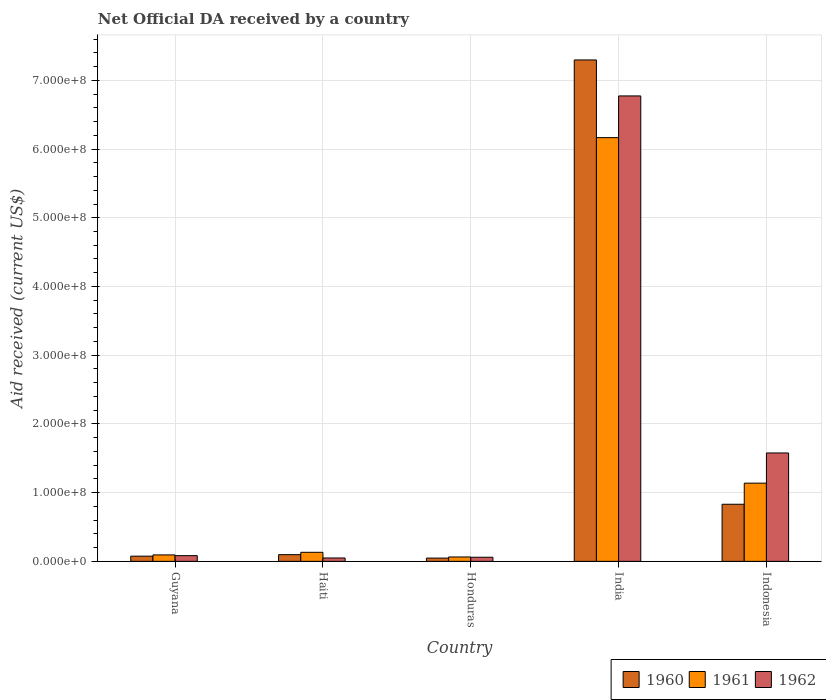How many different coloured bars are there?
Provide a succinct answer. 3. Are the number of bars per tick equal to the number of legend labels?
Your answer should be very brief. Yes. How many bars are there on the 2nd tick from the left?
Offer a terse response. 3. What is the net official development assistance aid received in 1962 in Haiti?
Give a very brief answer. 4.92e+06. Across all countries, what is the maximum net official development assistance aid received in 1960?
Provide a short and direct response. 7.30e+08. Across all countries, what is the minimum net official development assistance aid received in 1960?
Make the answer very short. 4.77e+06. In which country was the net official development assistance aid received in 1961 minimum?
Your answer should be very brief. Honduras. What is the total net official development assistance aid received in 1960 in the graph?
Offer a very short reply. 8.35e+08. What is the difference between the net official development assistance aid received in 1961 in India and that in Indonesia?
Give a very brief answer. 5.03e+08. What is the difference between the net official development assistance aid received in 1961 in India and the net official development assistance aid received in 1960 in Indonesia?
Offer a very short reply. 5.34e+08. What is the average net official development assistance aid received in 1960 per country?
Provide a short and direct response. 1.67e+08. What is the difference between the net official development assistance aid received of/in 1962 and net official development assistance aid received of/in 1961 in Guyana?
Ensure brevity in your answer.  -1.06e+06. What is the ratio of the net official development assistance aid received in 1962 in Honduras to that in Indonesia?
Provide a succinct answer. 0.04. Is the net official development assistance aid received in 1960 in Honduras less than that in India?
Offer a terse response. Yes. Is the difference between the net official development assistance aid received in 1962 in Guyana and Honduras greater than the difference between the net official development assistance aid received in 1961 in Guyana and Honduras?
Make the answer very short. No. What is the difference between the highest and the second highest net official development assistance aid received in 1961?
Make the answer very short. 5.03e+08. What is the difference between the highest and the lowest net official development assistance aid received in 1961?
Give a very brief answer. 6.10e+08. Is the sum of the net official development assistance aid received in 1961 in India and Indonesia greater than the maximum net official development assistance aid received in 1960 across all countries?
Your answer should be very brief. Yes. Is it the case that in every country, the sum of the net official development assistance aid received in 1960 and net official development assistance aid received in 1962 is greater than the net official development assistance aid received in 1961?
Make the answer very short. Yes. How many bars are there?
Offer a terse response. 15. Are all the bars in the graph horizontal?
Your response must be concise. No. How are the legend labels stacked?
Your answer should be compact. Horizontal. What is the title of the graph?
Your response must be concise. Net Official DA received by a country. What is the label or title of the Y-axis?
Provide a succinct answer. Aid received (current US$). What is the Aid received (current US$) of 1960 in Guyana?
Ensure brevity in your answer.  7.57e+06. What is the Aid received (current US$) of 1961 in Guyana?
Ensure brevity in your answer.  9.38e+06. What is the Aid received (current US$) in 1962 in Guyana?
Offer a very short reply. 8.32e+06. What is the Aid received (current US$) in 1960 in Haiti?
Give a very brief answer. 9.74e+06. What is the Aid received (current US$) of 1961 in Haiti?
Your response must be concise. 1.32e+07. What is the Aid received (current US$) in 1962 in Haiti?
Give a very brief answer. 4.92e+06. What is the Aid received (current US$) of 1960 in Honduras?
Your response must be concise. 4.77e+06. What is the Aid received (current US$) in 1961 in Honduras?
Offer a very short reply. 6.37e+06. What is the Aid received (current US$) of 1962 in Honduras?
Provide a succinct answer. 6.00e+06. What is the Aid received (current US$) in 1960 in India?
Provide a short and direct response. 7.30e+08. What is the Aid received (current US$) of 1961 in India?
Provide a succinct answer. 6.17e+08. What is the Aid received (current US$) in 1962 in India?
Give a very brief answer. 6.77e+08. What is the Aid received (current US$) in 1960 in Indonesia?
Your answer should be compact. 8.31e+07. What is the Aid received (current US$) in 1961 in Indonesia?
Provide a succinct answer. 1.14e+08. What is the Aid received (current US$) in 1962 in Indonesia?
Ensure brevity in your answer.  1.58e+08. Across all countries, what is the maximum Aid received (current US$) in 1960?
Keep it short and to the point. 7.30e+08. Across all countries, what is the maximum Aid received (current US$) of 1961?
Your response must be concise. 6.17e+08. Across all countries, what is the maximum Aid received (current US$) of 1962?
Offer a very short reply. 6.77e+08. Across all countries, what is the minimum Aid received (current US$) of 1960?
Provide a short and direct response. 4.77e+06. Across all countries, what is the minimum Aid received (current US$) of 1961?
Your response must be concise. 6.37e+06. Across all countries, what is the minimum Aid received (current US$) of 1962?
Provide a short and direct response. 4.92e+06. What is the total Aid received (current US$) in 1960 in the graph?
Your answer should be compact. 8.35e+08. What is the total Aid received (current US$) of 1961 in the graph?
Your response must be concise. 7.59e+08. What is the total Aid received (current US$) of 1962 in the graph?
Offer a very short reply. 8.54e+08. What is the difference between the Aid received (current US$) of 1960 in Guyana and that in Haiti?
Make the answer very short. -2.17e+06. What is the difference between the Aid received (current US$) of 1961 in Guyana and that in Haiti?
Your answer should be compact. -3.79e+06. What is the difference between the Aid received (current US$) of 1962 in Guyana and that in Haiti?
Give a very brief answer. 3.40e+06. What is the difference between the Aid received (current US$) of 1960 in Guyana and that in Honduras?
Your answer should be compact. 2.80e+06. What is the difference between the Aid received (current US$) in 1961 in Guyana and that in Honduras?
Provide a succinct answer. 3.01e+06. What is the difference between the Aid received (current US$) of 1962 in Guyana and that in Honduras?
Your response must be concise. 2.32e+06. What is the difference between the Aid received (current US$) in 1960 in Guyana and that in India?
Provide a short and direct response. -7.22e+08. What is the difference between the Aid received (current US$) of 1961 in Guyana and that in India?
Your answer should be compact. -6.07e+08. What is the difference between the Aid received (current US$) in 1962 in Guyana and that in India?
Give a very brief answer. -6.69e+08. What is the difference between the Aid received (current US$) of 1960 in Guyana and that in Indonesia?
Provide a short and direct response. -7.55e+07. What is the difference between the Aid received (current US$) of 1961 in Guyana and that in Indonesia?
Make the answer very short. -1.04e+08. What is the difference between the Aid received (current US$) of 1962 in Guyana and that in Indonesia?
Your answer should be very brief. -1.49e+08. What is the difference between the Aid received (current US$) of 1960 in Haiti and that in Honduras?
Offer a very short reply. 4.97e+06. What is the difference between the Aid received (current US$) in 1961 in Haiti and that in Honduras?
Make the answer very short. 6.80e+06. What is the difference between the Aid received (current US$) in 1962 in Haiti and that in Honduras?
Offer a terse response. -1.08e+06. What is the difference between the Aid received (current US$) in 1960 in Haiti and that in India?
Ensure brevity in your answer.  -7.20e+08. What is the difference between the Aid received (current US$) in 1961 in Haiti and that in India?
Keep it short and to the point. -6.03e+08. What is the difference between the Aid received (current US$) of 1962 in Haiti and that in India?
Your answer should be very brief. -6.72e+08. What is the difference between the Aid received (current US$) of 1960 in Haiti and that in Indonesia?
Offer a terse response. -7.33e+07. What is the difference between the Aid received (current US$) of 1961 in Haiti and that in Indonesia?
Ensure brevity in your answer.  -1.01e+08. What is the difference between the Aid received (current US$) of 1962 in Haiti and that in Indonesia?
Ensure brevity in your answer.  -1.53e+08. What is the difference between the Aid received (current US$) of 1960 in Honduras and that in India?
Keep it short and to the point. -7.25e+08. What is the difference between the Aid received (current US$) in 1961 in Honduras and that in India?
Ensure brevity in your answer.  -6.10e+08. What is the difference between the Aid received (current US$) of 1962 in Honduras and that in India?
Your answer should be compact. -6.71e+08. What is the difference between the Aid received (current US$) of 1960 in Honduras and that in Indonesia?
Your response must be concise. -7.83e+07. What is the difference between the Aid received (current US$) of 1961 in Honduras and that in Indonesia?
Your answer should be compact. -1.07e+08. What is the difference between the Aid received (current US$) in 1962 in Honduras and that in Indonesia?
Keep it short and to the point. -1.52e+08. What is the difference between the Aid received (current US$) of 1960 in India and that in Indonesia?
Your response must be concise. 6.47e+08. What is the difference between the Aid received (current US$) of 1961 in India and that in Indonesia?
Offer a terse response. 5.03e+08. What is the difference between the Aid received (current US$) of 1962 in India and that in Indonesia?
Offer a very short reply. 5.20e+08. What is the difference between the Aid received (current US$) in 1960 in Guyana and the Aid received (current US$) in 1961 in Haiti?
Keep it short and to the point. -5.60e+06. What is the difference between the Aid received (current US$) of 1960 in Guyana and the Aid received (current US$) of 1962 in Haiti?
Offer a very short reply. 2.65e+06. What is the difference between the Aid received (current US$) in 1961 in Guyana and the Aid received (current US$) in 1962 in Haiti?
Your answer should be compact. 4.46e+06. What is the difference between the Aid received (current US$) in 1960 in Guyana and the Aid received (current US$) in 1961 in Honduras?
Make the answer very short. 1.20e+06. What is the difference between the Aid received (current US$) of 1960 in Guyana and the Aid received (current US$) of 1962 in Honduras?
Provide a succinct answer. 1.57e+06. What is the difference between the Aid received (current US$) of 1961 in Guyana and the Aid received (current US$) of 1962 in Honduras?
Ensure brevity in your answer.  3.38e+06. What is the difference between the Aid received (current US$) of 1960 in Guyana and the Aid received (current US$) of 1961 in India?
Give a very brief answer. -6.09e+08. What is the difference between the Aid received (current US$) in 1960 in Guyana and the Aid received (current US$) in 1962 in India?
Offer a very short reply. -6.70e+08. What is the difference between the Aid received (current US$) in 1961 in Guyana and the Aid received (current US$) in 1962 in India?
Your answer should be compact. -6.68e+08. What is the difference between the Aid received (current US$) of 1960 in Guyana and the Aid received (current US$) of 1961 in Indonesia?
Your answer should be very brief. -1.06e+08. What is the difference between the Aid received (current US$) in 1960 in Guyana and the Aid received (current US$) in 1962 in Indonesia?
Offer a very short reply. -1.50e+08. What is the difference between the Aid received (current US$) of 1961 in Guyana and the Aid received (current US$) of 1962 in Indonesia?
Your answer should be compact. -1.48e+08. What is the difference between the Aid received (current US$) in 1960 in Haiti and the Aid received (current US$) in 1961 in Honduras?
Ensure brevity in your answer.  3.37e+06. What is the difference between the Aid received (current US$) of 1960 in Haiti and the Aid received (current US$) of 1962 in Honduras?
Offer a very short reply. 3.74e+06. What is the difference between the Aid received (current US$) in 1961 in Haiti and the Aid received (current US$) in 1962 in Honduras?
Your answer should be very brief. 7.17e+06. What is the difference between the Aid received (current US$) in 1960 in Haiti and the Aid received (current US$) in 1961 in India?
Provide a short and direct response. -6.07e+08. What is the difference between the Aid received (current US$) in 1960 in Haiti and the Aid received (current US$) in 1962 in India?
Keep it short and to the point. -6.68e+08. What is the difference between the Aid received (current US$) of 1961 in Haiti and the Aid received (current US$) of 1962 in India?
Make the answer very short. -6.64e+08. What is the difference between the Aid received (current US$) in 1960 in Haiti and the Aid received (current US$) in 1961 in Indonesia?
Ensure brevity in your answer.  -1.04e+08. What is the difference between the Aid received (current US$) of 1960 in Haiti and the Aid received (current US$) of 1962 in Indonesia?
Ensure brevity in your answer.  -1.48e+08. What is the difference between the Aid received (current US$) in 1961 in Haiti and the Aid received (current US$) in 1962 in Indonesia?
Provide a short and direct response. -1.45e+08. What is the difference between the Aid received (current US$) of 1960 in Honduras and the Aid received (current US$) of 1961 in India?
Your answer should be compact. -6.12e+08. What is the difference between the Aid received (current US$) of 1960 in Honduras and the Aid received (current US$) of 1962 in India?
Your response must be concise. -6.72e+08. What is the difference between the Aid received (current US$) in 1961 in Honduras and the Aid received (current US$) in 1962 in India?
Give a very brief answer. -6.71e+08. What is the difference between the Aid received (current US$) of 1960 in Honduras and the Aid received (current US$) of 1961 in Indonesia?
Offer a very short reply. -1.09e+08. What is the difference between the Aid received (current US$) of 1960 in Honduras and the Aid received (current US$) of 1962 in Indonesia?
Provide a succinct answer. -1.53e+08. What is the difference between the Aid received (current US$) of 1961 in Honduras and the Aid received (current US$) of 1962 in Indonesia?
Your response must be concise. -1.51e+08. What is the difference between the Aid received (current US$) in 1960 in India and the Aid received (current US$) in 1961 in Indonesia?
Offer a terse response. 6.16e+08. What is the difference between the Aid received (current US$) of 1960 in India and the Aid received (current US$) of 1962 in Indonesia?
Your answer should be compact. 5.72e+08. What is the difference between the Aid received (current US$) of 1961 in India and the Aid received (current US$) of 1962 in Indonesia?
Your answer should be compact. 4.59e+08. What is the average Aid received (current US$) in 1960 per country?
Provide a short and direct response. 1.67e+08. What is the average Aid received (current US$) in 1961 per country?
Your response must be concise. 1.52e+08. What is the average Aid received (current US$) in 1962 per country?
Your response must be concise. 1.71e+08. What is the difference between the Aid received (current US$) of 1960 and Aid received (current US$) of 1961 in Guyana?
Ensure brevity in your answer.  -1.81e+06. What is the difference between the Aid received (current US$) in 1960 and Aid received (current US$) in 1962 in Guyana?
Provide a short and direct response. -7.50e+05. What is the difference between the Aid received (current US$) of 1961 and Aid received (current US$) of 1962 in Guyana?
Your response must be concise. 1.06e+06. What is the difference between the Aid received (current US$) in 1960 and Aid received (current US$) in 1961 in Haiti?
Your answer should be compact. -3.43e+06. What is the difference between the Aid received (current US$) in 1960 and Aid received (current US$) in 1962 in Haiti?
Your answer should be very brief. 4.82e+06. What is the difference between the Aid received (current US$) of 1961 and Aid received (current US$) of 1962 in Haiti?
Provide a short and direct response. 8.25e+06. What is the difference between the Aid received (current US$) of 1960 and Aid received (current US$) of 1961 in Honduras?
Your response must be concise. -1.60e+06. What is the difference between the Aid received (current US$) in 1960 and Aid received (current US$) in 1962 in Honduras?
Your response must be concise. -1.23e+06. What is the difference between the Aid received (current US$) in 1961 and Aid received (current US$) in 1962 in Honduras?
Offer a very short reply. 3.70e+05. What is the difference between the Aid received (current US$) in 1960 and Aid received (current US$) in 1961 in India?
Make the answer very short. 1.13e+08. What is the difference between the Aid received (current US$) of 1960 and Aid received (current US$) of 1962 in India?
Provide a short and direct response. 5.24e+07. What is the difference between the Aid received (current US$) of 1961 and Aid received (current US$) of 1962 in India?
Provide a succinct answer. -6.07e+07. What is the difference between the Aid received (current US$) in 1960 and Aid received (current US$) in 1961 in Indonesia?
Give a very brief answer. -3.07e+07. What is the difference between the Aid received (current US$) in 1960 and Aid received (current US$) in 1962 in Indonesia?
Provide a succinct answer. -7.46e+07. What is the difference between the Aid received (current US$) in 1961 and Aid received (current US$) in 1962 in Indonesia?
Offer a terse response. -4.39e+07. What is the ratio of the Aid received (current US$) of 1960 in Guyana to that in Haiti?
Give a very brief answer. 0.78. What is the ratio of the Aid received (current US$) of 1961 in Guyana to that in Haiti?
Provide a short and direct response. 0.71. What is the ratio of the Aid received (current US$) of 1962 in Guyana to that in Haiti?
Make the answer very short. 1.69. What is the ratio of the Aid received (current US$) of 1960 in Guyana to that in Honduras?
Your answer should be compact. 1.59. What is the ratio of the Aid received (current US$) of 1961 in Guyana to that in Honduras?
Provide a short and direct response. 1.47. What is the ratio of the Aid received (current US$) of 1962 in Guyana to that in Honduras?
Your answer should be compact. 1.39. What is the ratio of the Aid received (current US$) in 1960 in Guyana to that in India?
Provide a succinct answer. 0.01. What is the ratio of the Aid received (current US$) in 1961 in Guyana to that in India?
Offer a terse response. 0.02. What is the ratio of the Aid received (current US$) of 1962 in Guyana to that in India?
Offer a very short reply. 0.01. What is the ratio of the Aid received (current US$) in 1960 in Guyana to that in Indonesia?
Your answer should be very brief. 0.09. What is the ratio of the Aid received (current US$) of 1961 in Guyana to that in Indonesia?
Offer a terse response. 0.08. What is the ratio of the Aid received (current US$) of 1962 in Guyana to that in Indonesia?
Give a very brief answer. 0.05. What is the ratio of the Aid received (current US$) of 1960 in Haiti to that in Honduras?
Offer a terse response. 2.04. What is the ratio of the Aid received (current US$) of 1961 in Haiti to that in Honduras?
Keep it short and to the point. 2.07. What is the ratio of the Aid received (current US$) of 1962 in Haiti to that in Honduras?
Your response must be concise. 0.82. What is the ratio of the Aid received (current US$) of 1960 in Haiti to that in India?
Ensure brevity in your answer.  0.01. What is the ratio of the Aid received (current US$) in 1961 in Haiti to that in India?
Provide a short and direct response. 0.02. What is the ratio of the Aid received (current US$) of 1962 in Haiti to that in India?
Make the answer very short. 0.01. What is the ratio of the Aid received (current US$) of 1960 in Haiti to that in Indonesia?
Your response must be concise. 0.12. What is the ratio of the Aid received (current US$) in 1961 in Haiti to that in Indonesia?
Provide a succinct answer. 0.12. What is the ratio of the Aid received (current US$) of 1962 in Haiti to that in Indonesia?
Provide a succinct answer. 0.03. What is the ratio of the Aid received (current US$) in 1960 in Honduras to that in India?
Offer a terse response. 0.01. What is the ratio of the Aid received (current US$) in 1961 in Honduras to that in India?
Give a very brief answer. 0.01. What is the ratio of the Aid received (current US$) of 1962 in Honduras to that in India?
Provide a short and direct response. 0.01. What is the ratio of the Aid received (current US$) of 1960 in Honduras to that in Indonesia?
Offer a very short reply. 0.06. What is the ratio of the Aid received (current US$) in 1961 in Honduras to that in Indonesia?
Offer a very short reply. 0.06. What is the ratio of the Aid received (current US$) in 1962 in Honduras to that in Indonesia?
Offer a very short reply. 0.04. What is the ratio of the Aid received (current US$) in 1960 in India to that in Indonesia?
Your answer should be very brief. 8.78. What is the ratio of the Aid received (current US$) of 1961 in India to that in Indonesia?
Your answer should be compact. 5.42. What is the ratio of the Aid received (current US$) in 1962 in India to that in Indonesia?
Offer a terse response. 4.29. What is the difference between the highest and the second highest Aid received (current US$) in 1960?
Keep it short and to the point. 6.47e+08. What is the difference between the highest and the second highest Aid received (current US$) of 1961?
Give a very brief answer. 5.03e+08. What is the difference between the highest and the second highest Aid received (current US$) in 1962?
Keep it short and to the point. 5.20e+08. What is the difference between the highest and the lowest Aid received (current US$) in 1960?
Make the answer very short. 7.25e+08. What is the difference between the highest and the lowest Aid received (current US$) of 1961?
Provide a short and direct response. 6.10e+08. What is the difference between the highest and the lowest Aid received (current US$) of 1962?
Provide a succinct answer. 6.72e+08. 